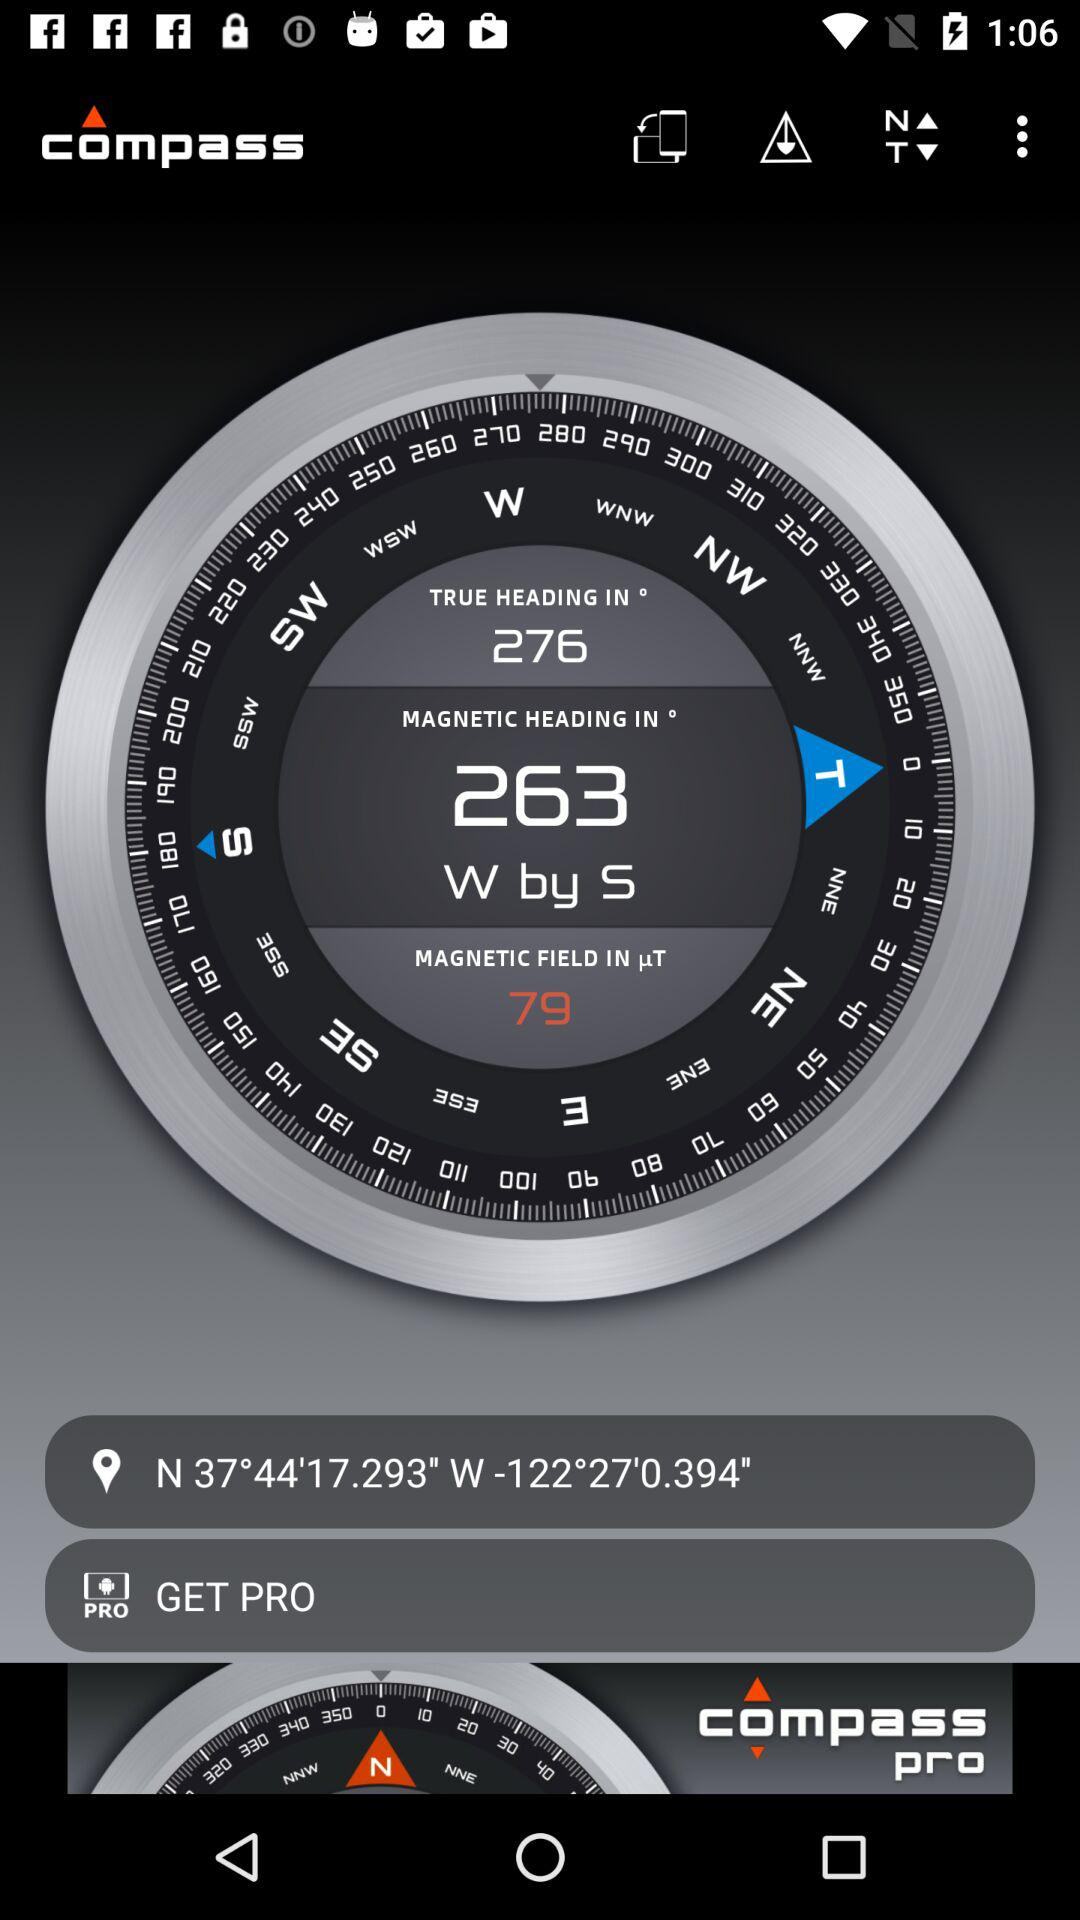What is the name of the application? The names of the applications are "compass" and "compass pro". 